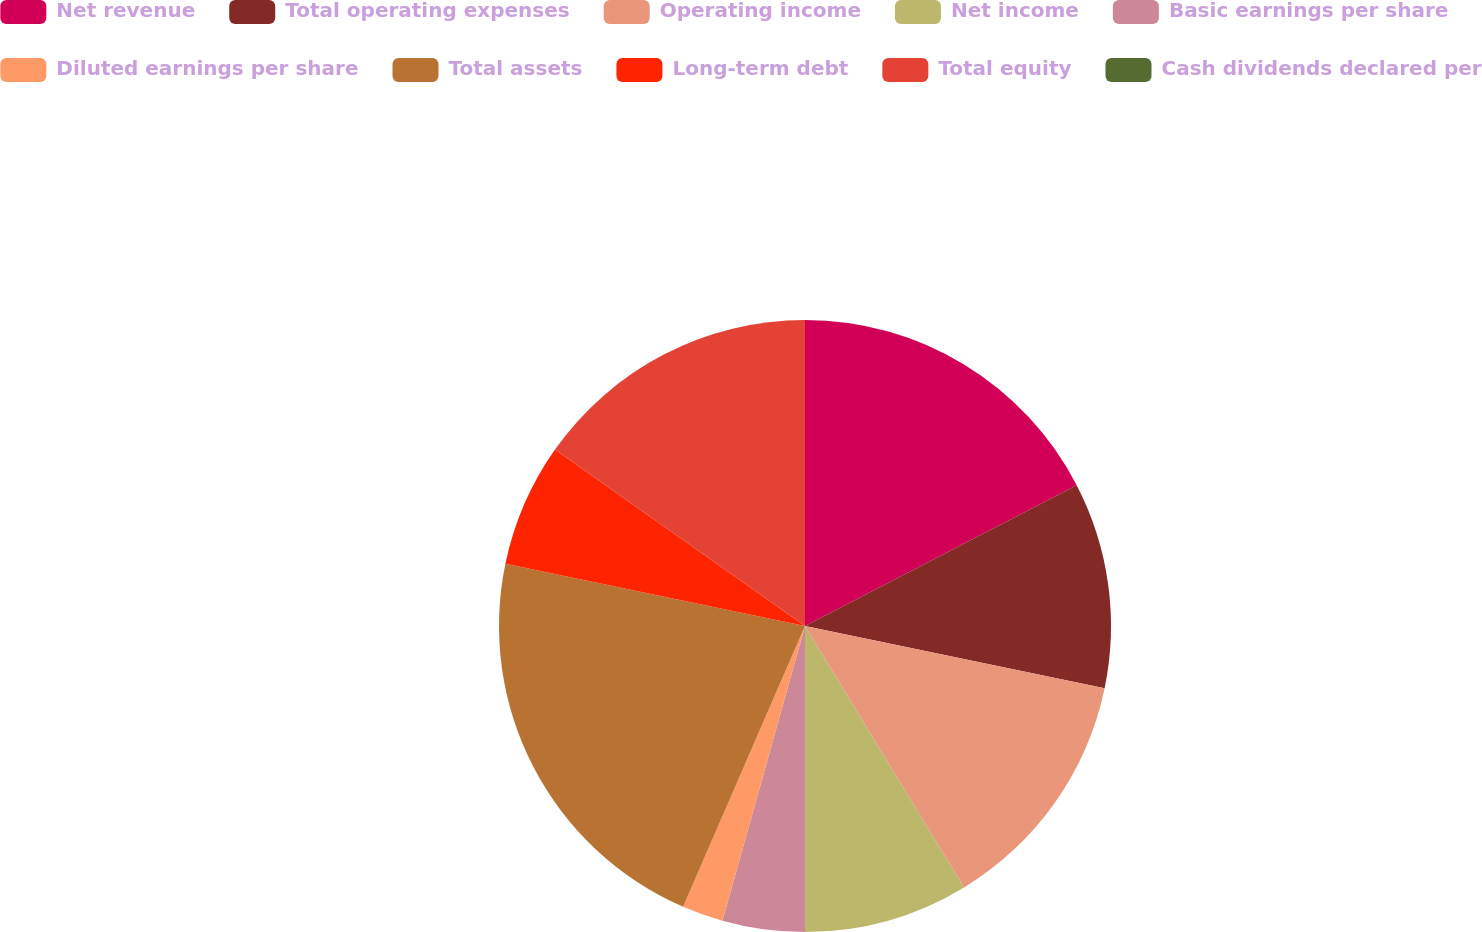Convert chart to OTSL. <chart><loc_0><loc_0><loc_500><loc_500><pie_chart><fcel>Net revenue<fcel>Total operating expenses<fcel>Operating income<fcel>Net income<fcel>Basic earnings per share<fcel>Diluted earnings per share<fcel>Total assets<fcel>Long-term debt<fcel>Total equity<fcel>Cash dividends declared per<nl><fcel>17.39%<fcel>10.87%<fcel>13.04%<fcel>8.7%<fcel>4.35%<fcel>2.17%<fcel>21.74%<fcel>6.52%<fcel>15.22%<fcel>0.0%<nl></chart> 